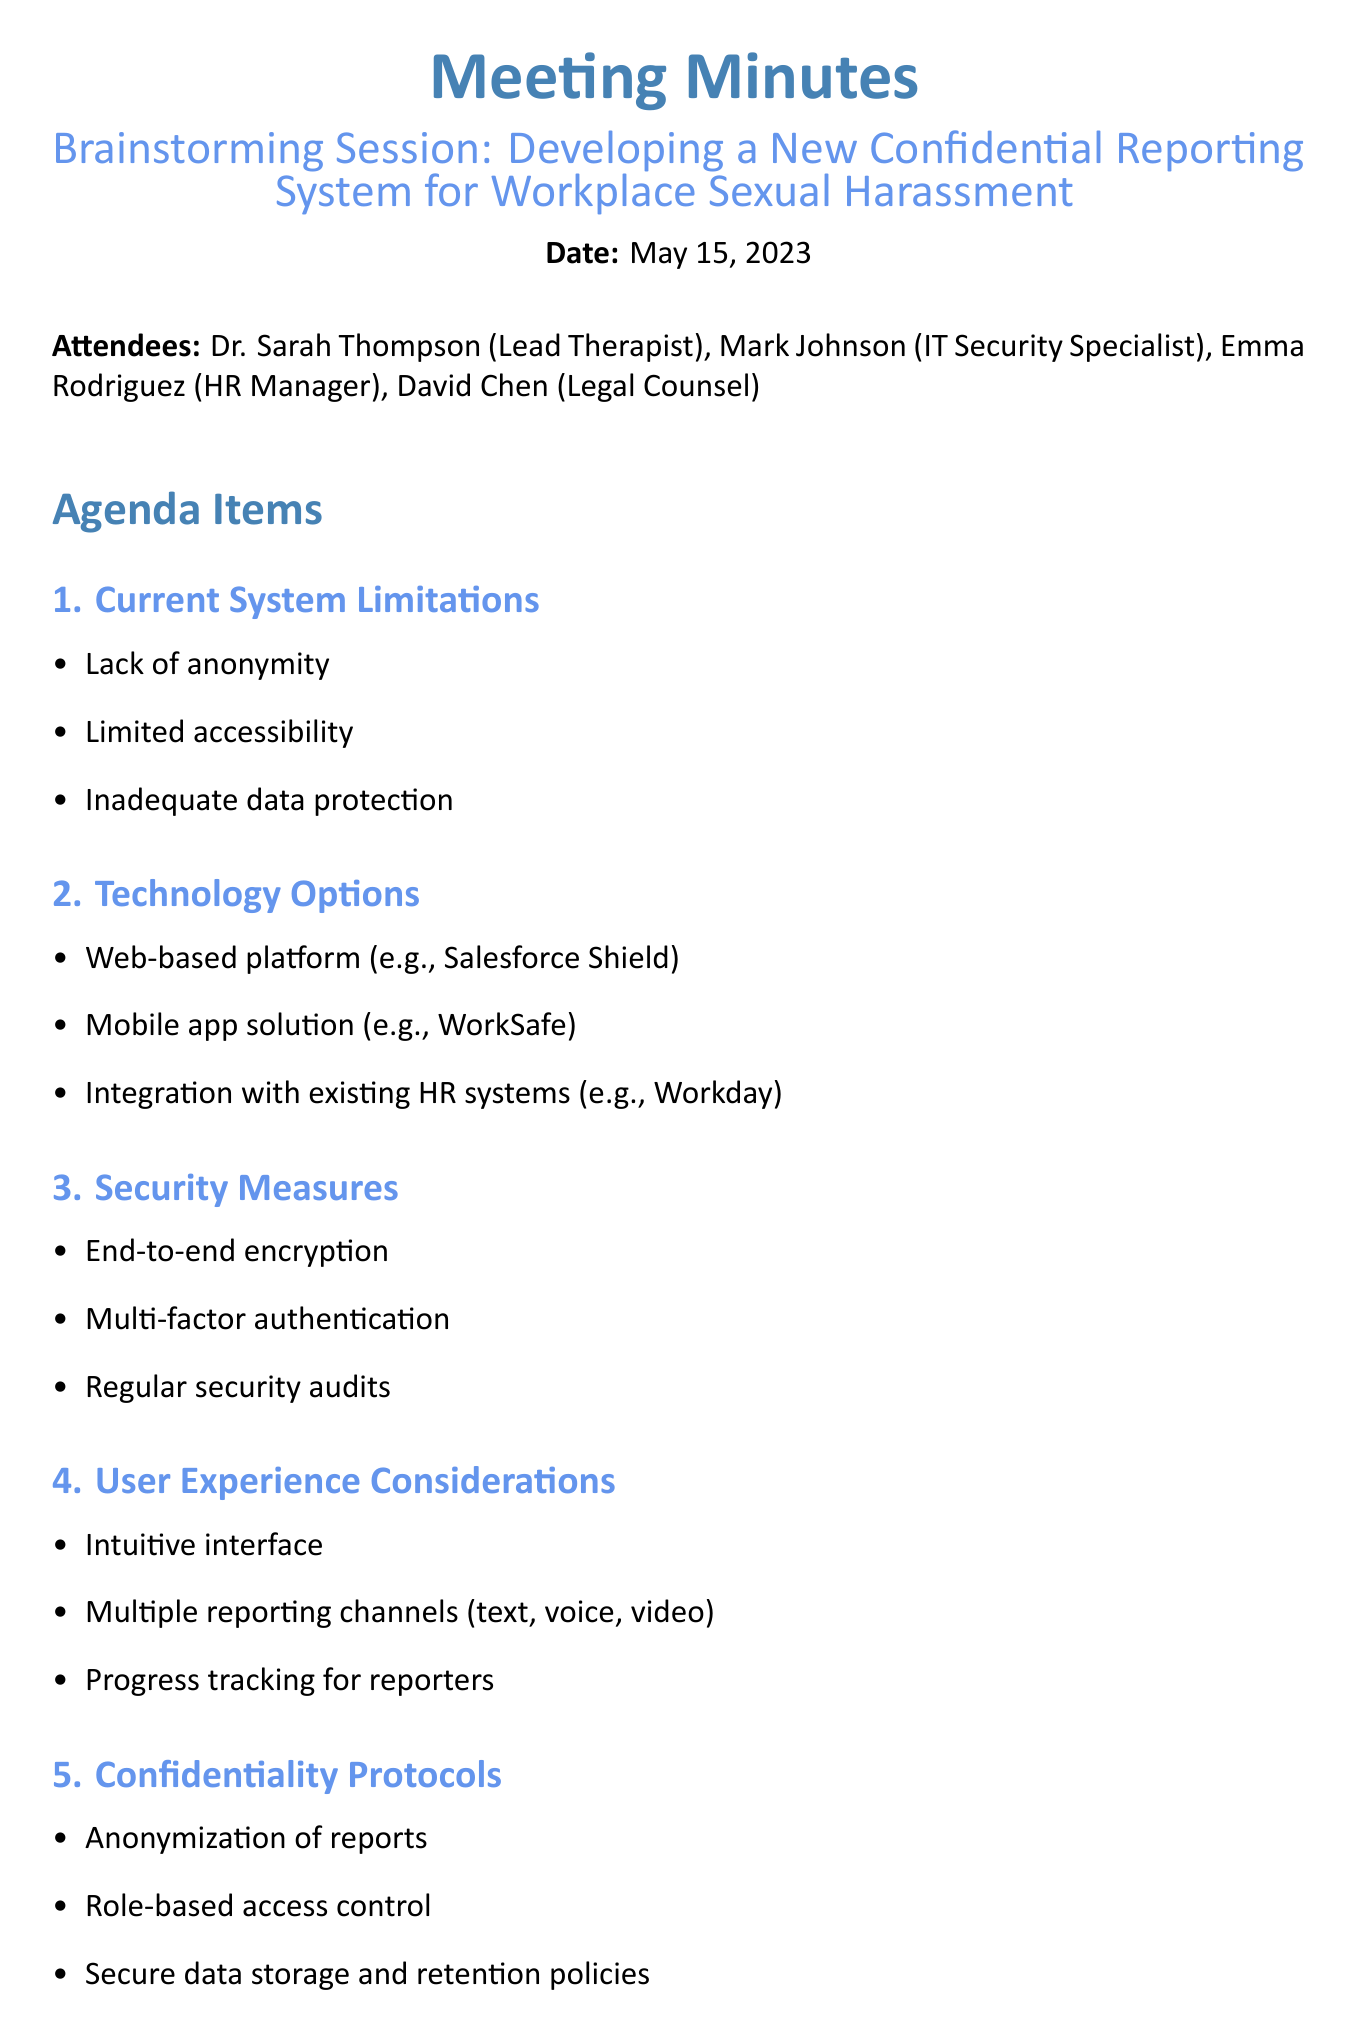What is the date of the meeting? The date of the meeting is stated clearly in the document.
Answer: May 15, 2023 Who is the Lead Therapist? The attendees section lists the Lead Therapist as Dr. Sarah Thompson.
Answer: Dr. Sarah Thompson What is one technology option mentioned? The Technology Options section lists several options, and one can be directly quoted.
Answer: Web-based platform (e.g., Salesforce Shield) What security measure is suggested for the new system? The Security Measures section enumerates specific measures to enhance security.
Answer: End-to-end encryption What is one limitation of the current system? The Current System Limitations section specifies various issues with the existing system.
Answer: Lack of anonymity How many attendees were present at the meeting? The attendees section lists the total number of individuals in attendance.
Answer: Four What is one user experience consideration mentioned? The User Experience Considerations section outlines specific improvements for user interaction.
Answer: Intuitive interface What is the first next step proposed? The Next Steps section sequentially lists actions to follow after the meeting.
Answer: Develop project timeline 